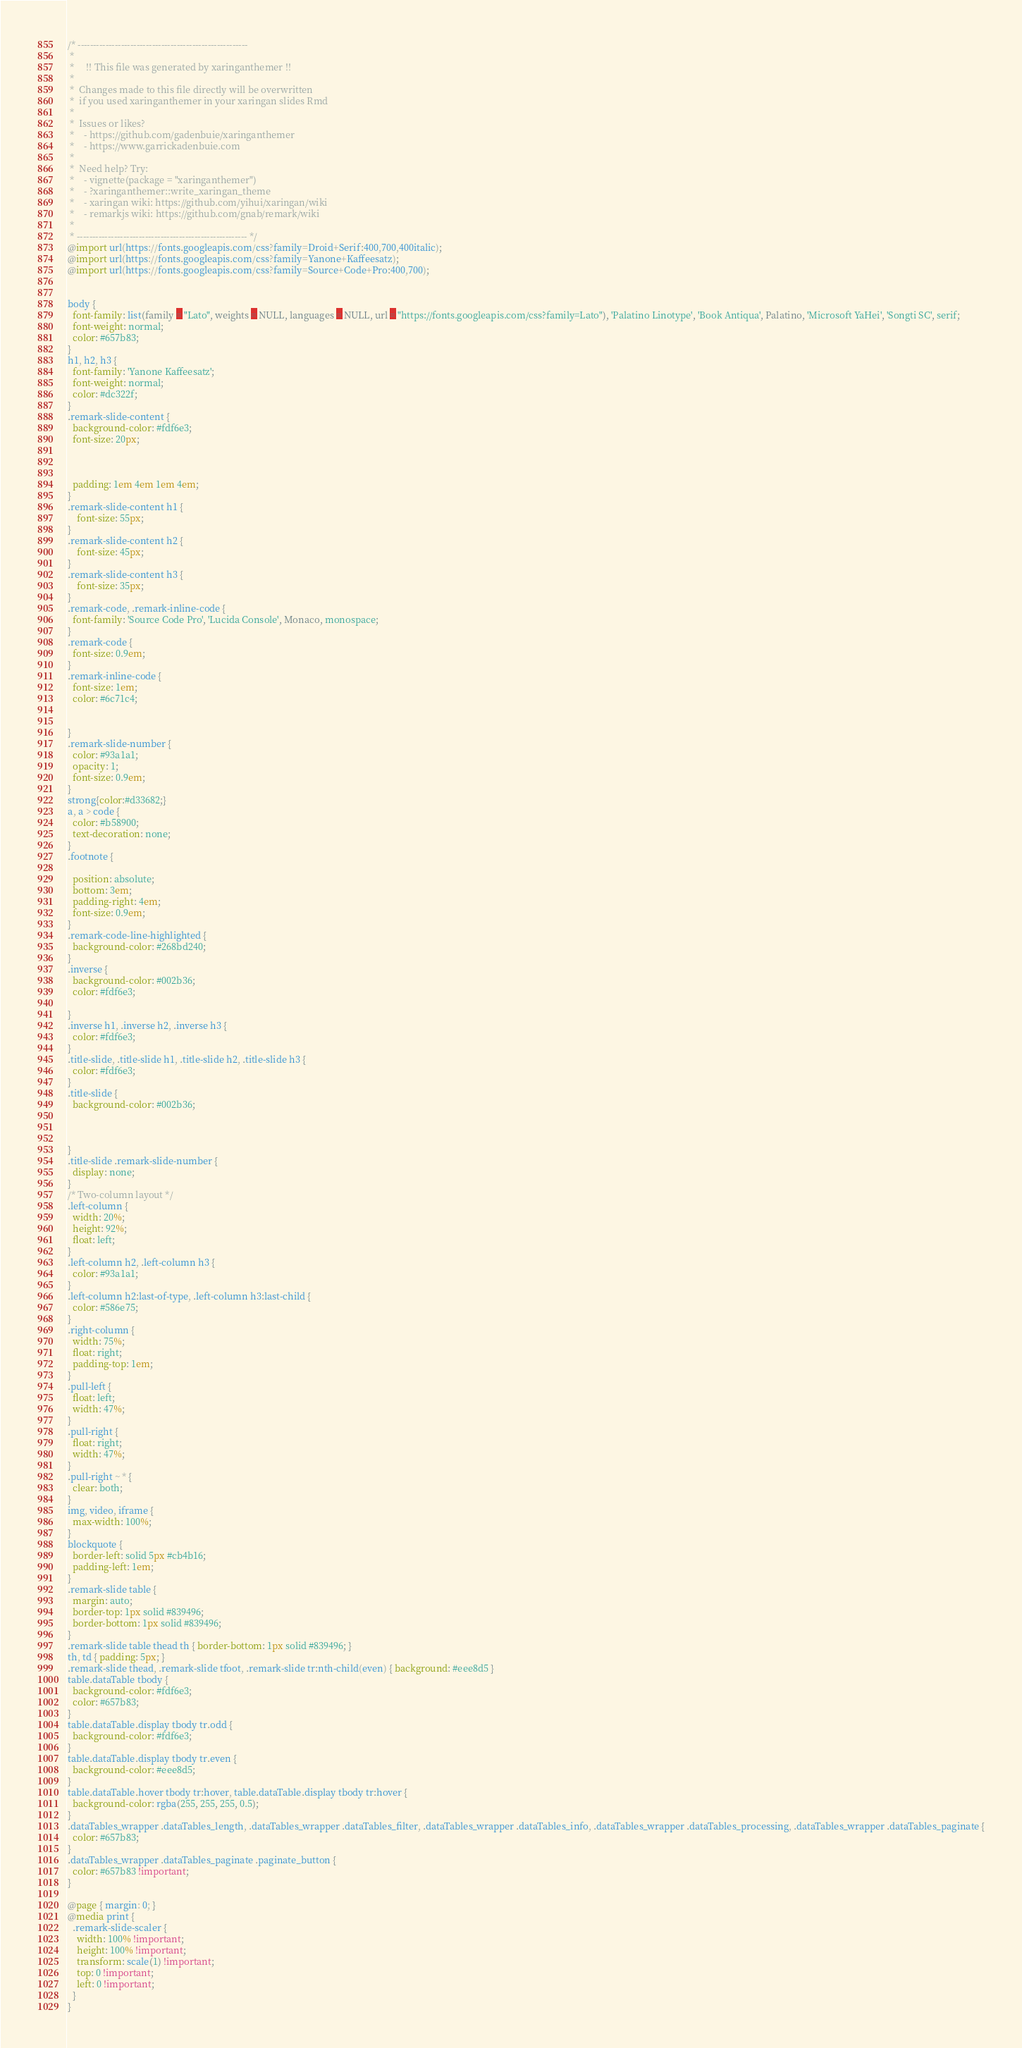<code> <loc_0><loc_0><loc_500><loc_500><_CSS_>/* -------------------------------------------------------
 *
 *     !! This file was generated by xaringanthemer !!
 *
 *  Changes made to this file directly will be overwritten
 *  if you used xaringanthemer in your xaringan slides Rmd
 *
 *  Issues or likes?
 *    - https://github.com/gadenbuie/xaringanthemer
 *    - https://www.garrickadenbuie.com
 *
 *  Need help? Try:
 *    - vignette(package = "xaringanthemer")
 *    - ?xaringanthemer::write_xaringan_theme
 *    - xaringan wiki: https://github.com/yihui/xaringan/wiki
 *    - remarkjs wiki: https://github.com/gnab/remark/wiki
 *
 * ------------------------------------------------------- */
@import url(https://fonts.googleapis.com/css?family=Droid+Serif:400,700,400italic);
@import url(https://fonts.googleapis.com/css?family=Yanone+Kaffeesatz);
@import url(https://fonts.googleapis.com/css?family=Source+Code+Pro:400,700);


body {
  font-family: list(family = "Lato", weights = NULL, languages = NULL, url = "https://fonts.googleapis.com/css?family=Lato"), 'Palatino Linotype', 'Book Antiqua', Palatino, 'Microsoft YaHei', 'Songti SC', serif;
  font-weight: normal;
  color: #657b83;
}
h1, h2, h3 {
  font-family: 'Yanone Kaffeesatz';
  font-weight: normal;
  color: #dc322f;
}
.remark-slide-content {
  background-color: #fdf6e3;
  font-size: 20px;
  
  
  
  padding: 1em 4em 1em 4em;
}
.remark-slide-content h1 {
    font-size: 55px;
}
.remark-slide-content h2 {
    font-size: 45px;
}
.remark-slide-content h3 {
    font-size: 35px;
}
.remark-code, .remark-inline-code {
  font-family: 'Source Code Pro', 'Lucida Console', Monaco, monospace;
}
.remark-code {
  font-size: 0.9em;
}
.remark-inline-code {
  font-size: 1em;
  color: #6c71c4;
  
  
}
.remark-slide-number {
  color: #93a1a1;
  opacity: 1;
  font-size: 0.9em;
}
strong{color:#d33682;}
a, a > code {
  color: #b58900;
  text-decoration: none;
}
.footnote {
  
  position: absolute;
  bottom: 3em;
  padding-right: 4em;
  font-size: 0.9em;
}
.remark-code-line-highlighted {
  background-color: #268bd240;
}
.inverse {
  background-color: #002b36;
  color: #fdf6e3;
  
}
.inverse h1, .inverse h2, .inverse h3 {
  color: #fdf6e3;
}
.title-slide, .title-slide h1, .title-slide h2, .title-slide h3 {
  color: #fdf6e3;
}
.title-slide {
  background-color: #002b36;
  
  
  
}
.title-slide .remark-slide-number {
  display: none;
}
/* Two-column layout */
.left-column {
  width: 20%;
  height: 92%;
  float: left;
}
.left-column h2, .left-column h3 {
  color: #93a1a1;
}
.left-column h2:last-of-type, .left-column h3:last-child {
  color: #586e75;
}
.right-column {
  width: 75%;
  float: right;
  padding-top: 1em;
}
.pull-left {
  float: left;
  width: 47%;
}
.pull-right {
  float: right;
  width: 47%;
}
.pull-right ~ * {
  clear: both;
}
img, video, iframe {
  max-width: 100%;
}
blockquote {
  border-left: solid 5px #cb4b16;
  padding-left: 1em;
}
.remark-slide table {
  margin: auto;
  border-top: 1px solid #839496;
  border-bottom: 1px solid #839496;
}
.remark-slide table thead th { border-bottom: 1px solid #839496; }
th, td { padding: 5px; }
.remark-slide thead, .remark-slide tfoot, .remark-slide tr:nth-child(even) { background: #eee8d5 }
table.dataTable tbody {
  background-color: #fdf6e3;
  color: #657b83;
}
table.dataTable.display tbody tr.odd {
  background-color: #fdf6e3;
}
table.dataTable.display tbody tr.even {
  background-color: #eee8d5;
}
table.dataTable.hover tbody tr:hover, table.dataTable.display tbody tr:hover {
  background-color: rgba(255, 255, 255, 0.5);
}
.dataTables_wrapper .dataTables_length, .dataTables_wrapper .dataTables_filter, .dataTables_wrapper .dataTables_info, .dataTables_wrapper .dataTables_processing, .dataTables_wrapper .dataTables_paginate {
  color: #657b83;
}
.dataTables_wrapper .dataTables_paginate .paginate_button {
  color: #657b83 !important;
}

@page { margin: 0; }
@media print {
  .remark-slide-scaler {
    width: 100% !important;
    height: 100% !important;
    transform: scale(1) !important;
    top: 0 !important;
    left: 0 !important;
  }
}
</code> 